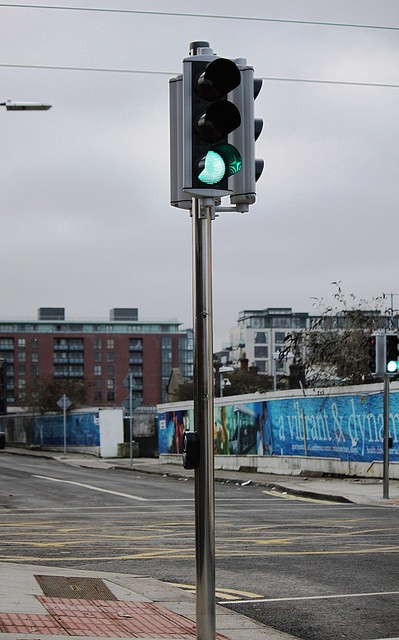Describe the objects in this image and their specific colors. I can see traffic light in lightgray, black, and gray tones and traffic light in lightgray, black, purple, white, and gray tones in this image. 